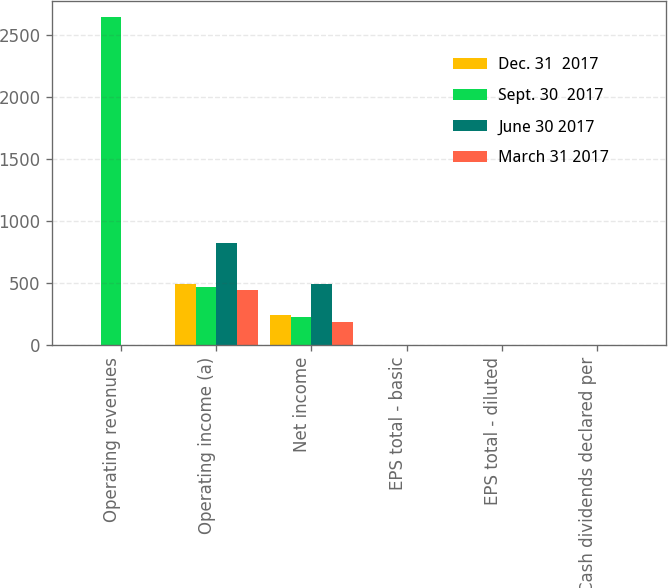Convert chart to OTSL. <chart><loc_0><loc_0><loc_500><loc_500><stacked_bar_chart><ecel><fcel>Operating revenues<fcel>Operating income (a)<fcel>Net income<fcel>EPS total - basic<fcel>EPS total - diluted<fcel>Cash dividends declared per<nl><fcel>Dec. 31  2017<fcel>0.97<fcel>492<fcel>239<fcel>0.47<fcel>0.47<fcel>0.36<nl><fcel>Sept. 30  2017<fcel>2645<fcel>466<fcel>227<fcel>0.45<fcel>0.45<fcel>0.36<nl><fcel>June 30 2017<fcel>0.97<fcel>824<fcel>492<fcel>0.97<fcel>0.97<fcel>0.36<nl><fcel>March 31 2017<fcel>0.97<fcel>440<fcel>189<fcel>0.37<fcel>0.37<fcel>0.36<nl></chart> 